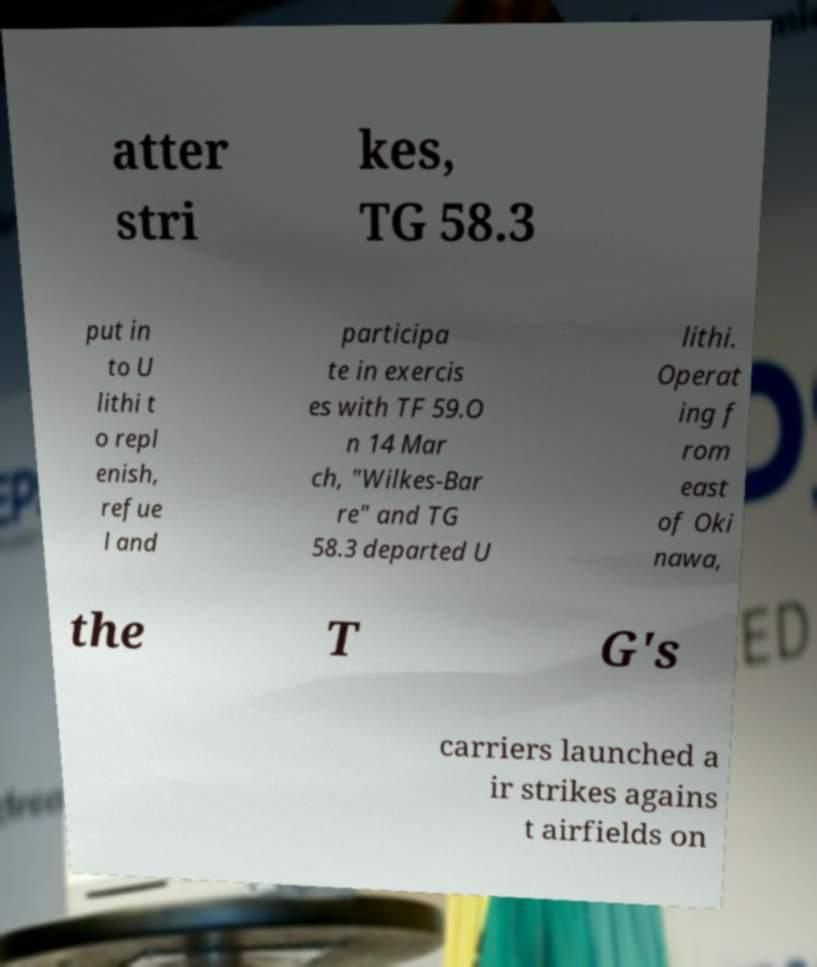I need the written content from this picture converted into text. Can you do that? atter stri kes, TG 58.3 put in to U lithi t o repl enish, refue l and participa te in exercis es with TF 59.O n 14 Mar ch, "Wilkes-Bar re" and TG 58.3 departed U lithi. Operat ing f rom east of Oki nawa, the T G's carriers launched a ir strikes agains t airfields on 